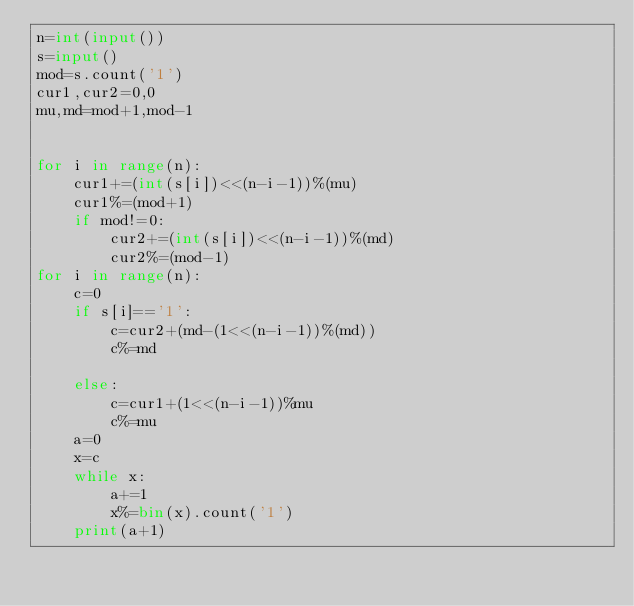<code> <loc_0><loc_0><loc_500><loc_500><_Python_>n=int(input())
s=input()
mod=s.count('1')
cur1,cur2=0,0
mu,md=mod+1,mod-1


for i in range(n):
    cur1+=(int(s[i])<<(n-i-1))%(mu)
    cur1%=(mod+1)
    if mod!=0:
        cur2+=(int(s[i])<<(n-i-1))%(md)
        cur2%=(mod-1)
for i in range(n):
    c=0
    if s[i]=='1':
        c=cur2+(md-(1<<(n-i-1))%(md))
        c%=md
        
    else:
        c=cur1+(1<<(n-i-1))%mu
        c%=mu
    a=0
    x=c
    while x:
        a+=1
        x%=bin(x).count('1')
    print(a+1)
</code> 